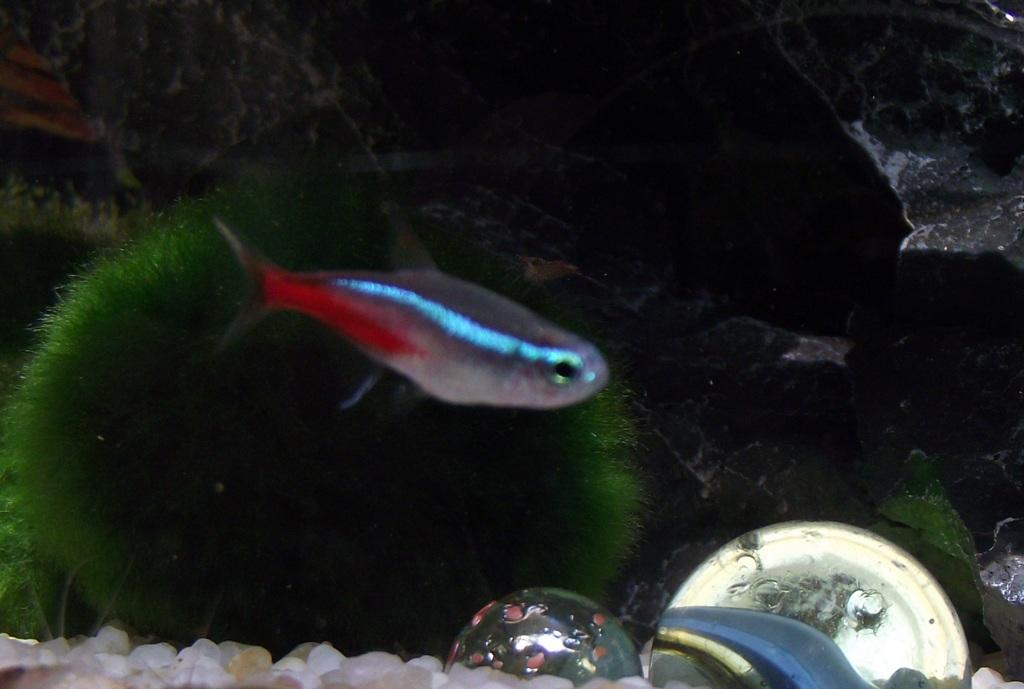What is in the water in the image? There is a fish, plants, marbles, and pebbles in the water. What colors can be seen on the fish? The fish has blue, red, and grey colors. What type of objects are present at the bottom of the water? There are plants at the bottom of the water. What other objects can be found in the water besides the fish? There are marbles and pebbles in the water. What type of window can be seen in the image? There is no window present in the image; it features a fish in water with plants, marbles, and pebbles. What type of oatmeal is being served in the image? There is no oatmeal present in the image; it features a fish in water with plants, marbles, and pebbles. 